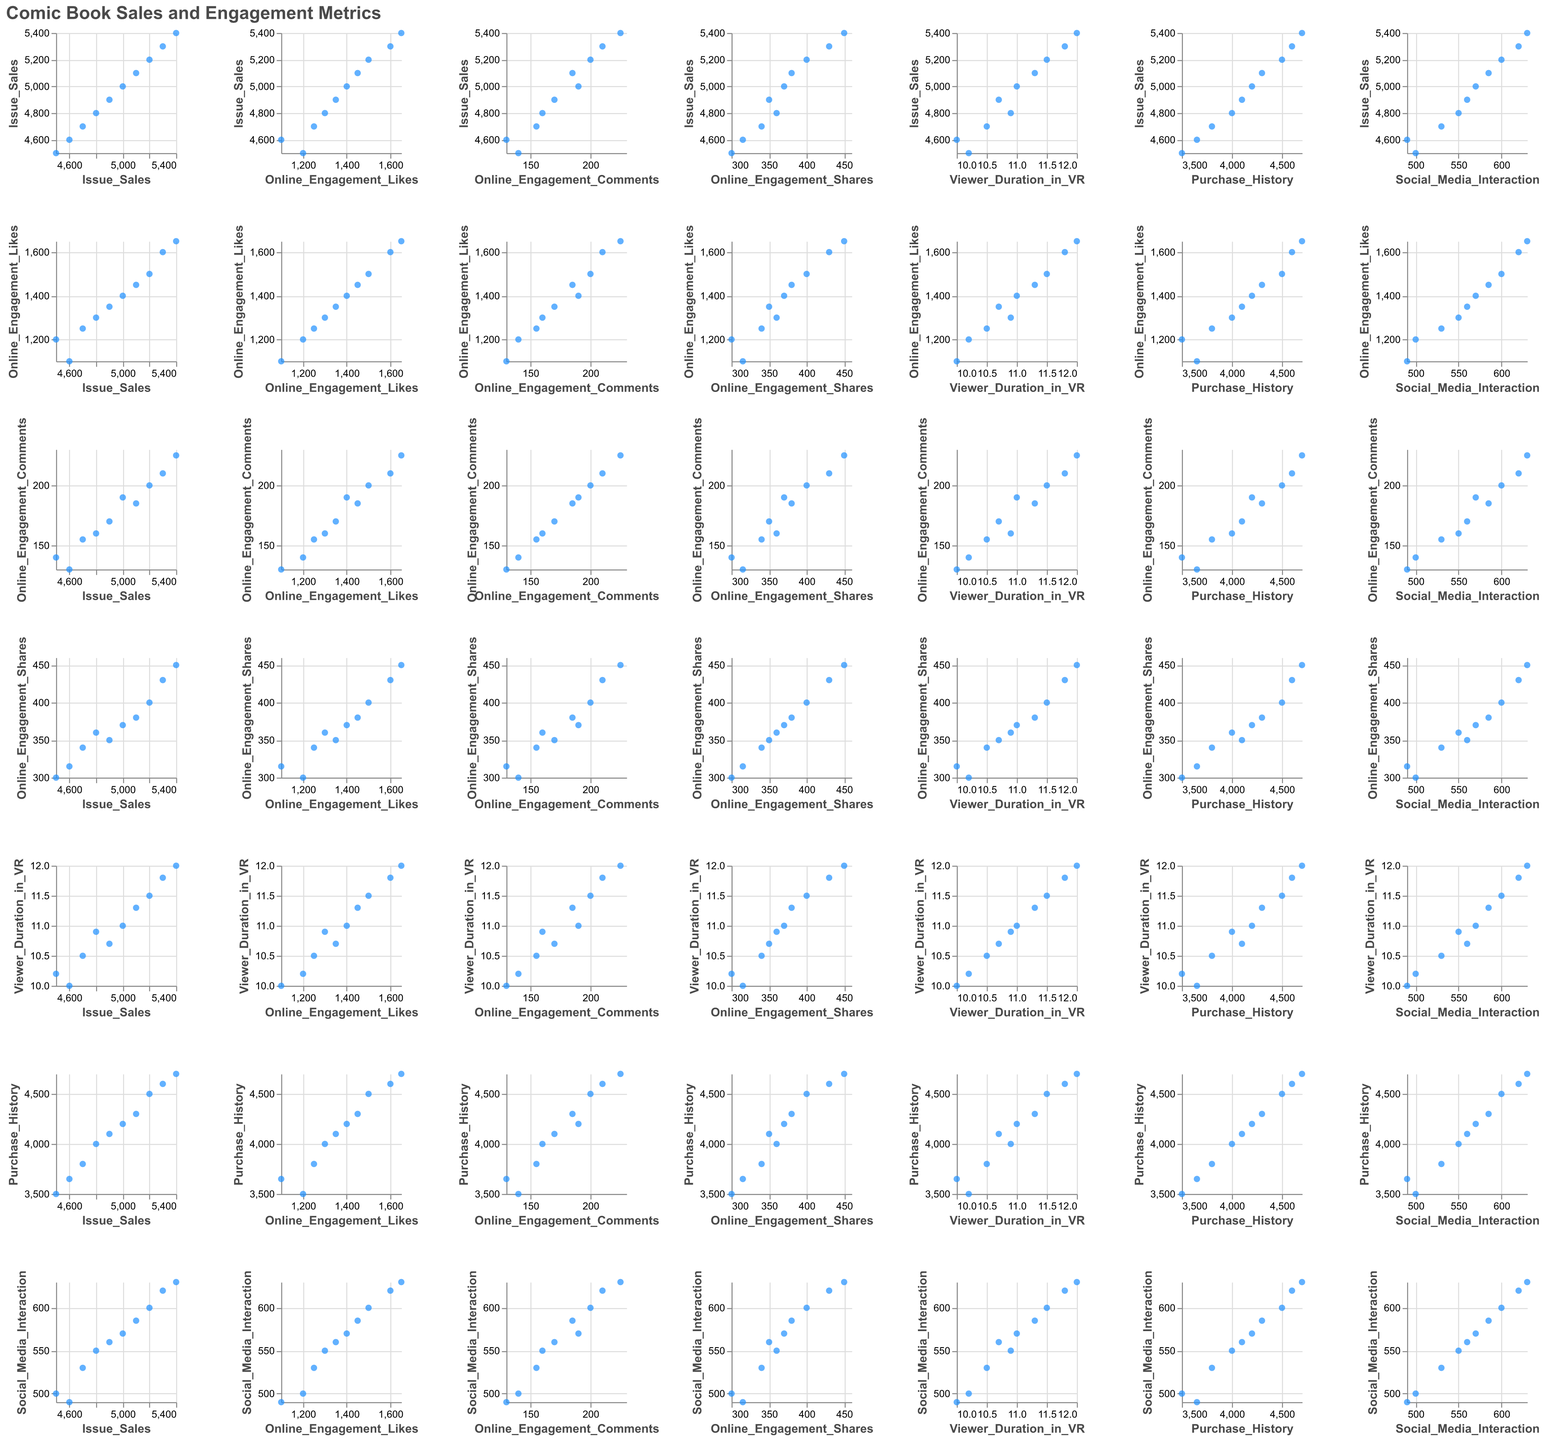what's the title of the figure? The title can be found at the top of the figure. It gives a brief idea about the content represented in the figure. Here, the title is "Comic Book Sales and Engagement Metrics."
Answer: Comic Book Sales and Engagement Metrics how many data points are plotted in each individual scatter plot? By counting the number of rows in the given data table, we can determine how many data points are plotted. Each row represents a data point, and there are 10 rows in total.
Answer: 10 which variable appears to have the strongest positive correlation with Issue Sales? By visually comparing each scatter plot in the matrix, we notice that the scatter plot of Issue Sales vs. Online Engagement Likes shows a strong positive linear relationship. As the number of online engagement likes increases, the issue sales also increase.
Answer: Online Engagement Likes what is the median Online Engagement Comments value? To find the median, we first sort the number of Online Engagement Comments: 130, 140, 155, 160, 170, 185, 190, 200, 210, 225. Since there are 10 data points, the median is the average of the 5th and 6th values. (170+185)/2 = 177.5
Answer: 177.5 which variable shows the least amount of variability? By comparing the scatter plots, we observe that Viewer Duration in VR has the least amount of spread in its values, indicating low variability. Most data points are clustered closely around the mean.
Answer: Viewer Duration in VR is the average social media interaction higher for issues with more than 5000 sales? Issues with sales greater than 5000 have the following Social Media Interaction values: 600, 620, 630, 585. The sum is 2435, and the average is 2435/4 = 608.75. For issues with sales of 5000 and below, Social Media Interaction values are 500, 550, 530, 570, 560, 490. The sum is 3200, and the average is 3200/6 = 533.33.
Answer: Yes do Viewer Duration in VR and Purchase History show any noticeable relationship? By observing the scatter plot of Viewer Duration in VR vs. Purchase History, we see a weak positive correlation. As the time spent in VR increases, there is a slight tendency for the purchase history value to also increase.
Answer: Weak positive relationship what is the range of the Online Engagement Shares? The range is determined by finding the difference between the maximum and minimum values. The minimum value is 300, and the maximum value is 450. Therefore, the range is 450 - 300 = 150.
Answer: 150 